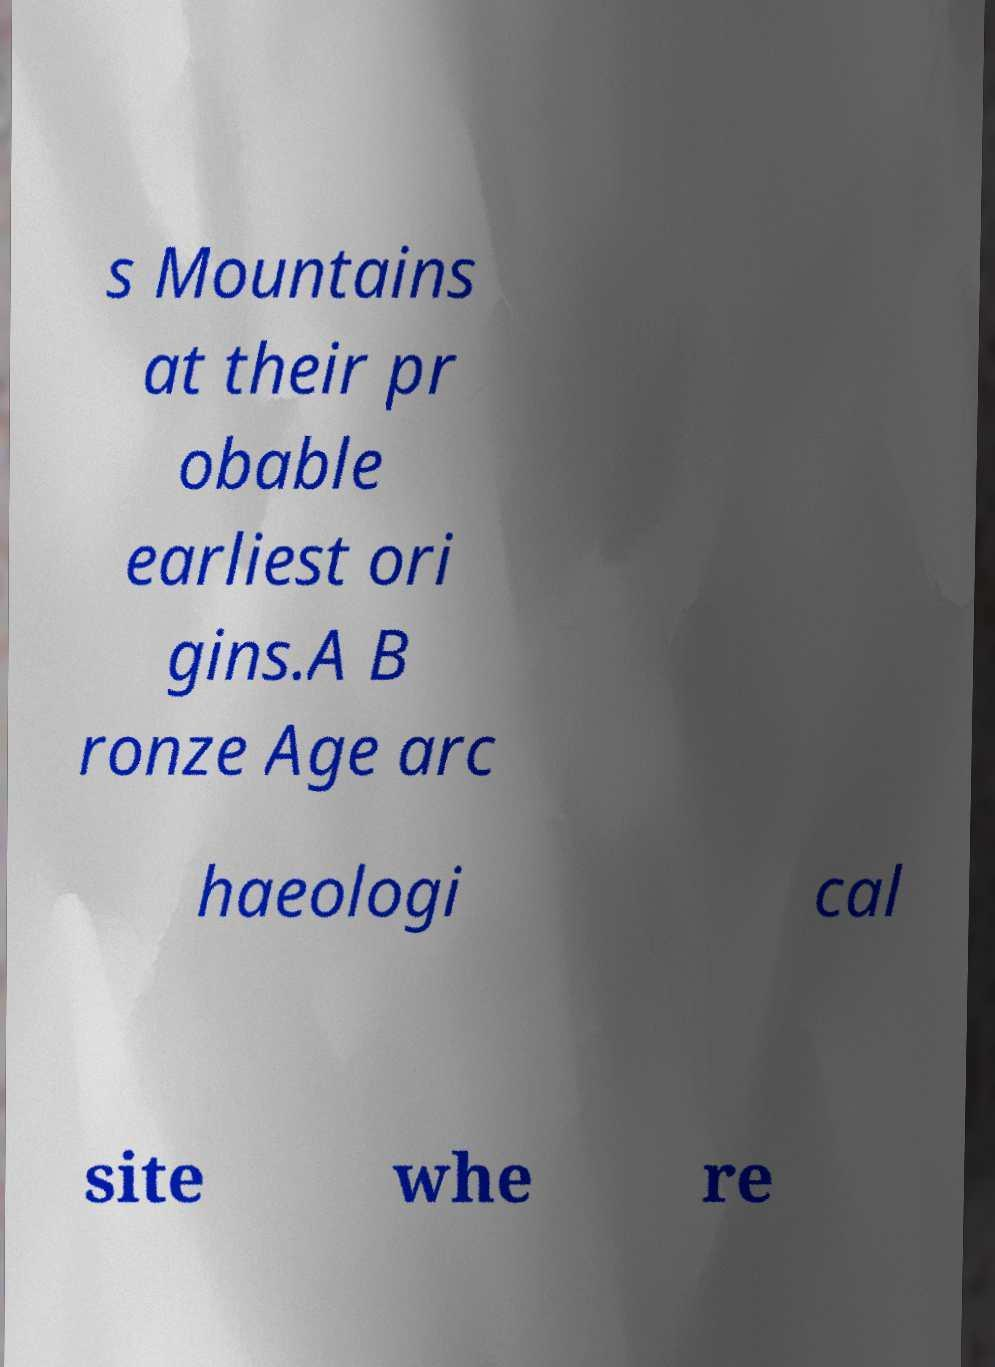Please identify and transcribe the text found in this image. s Mountains at their pr obable earliest ori gins.A B ronze Age arc haeologi cal site whe re 